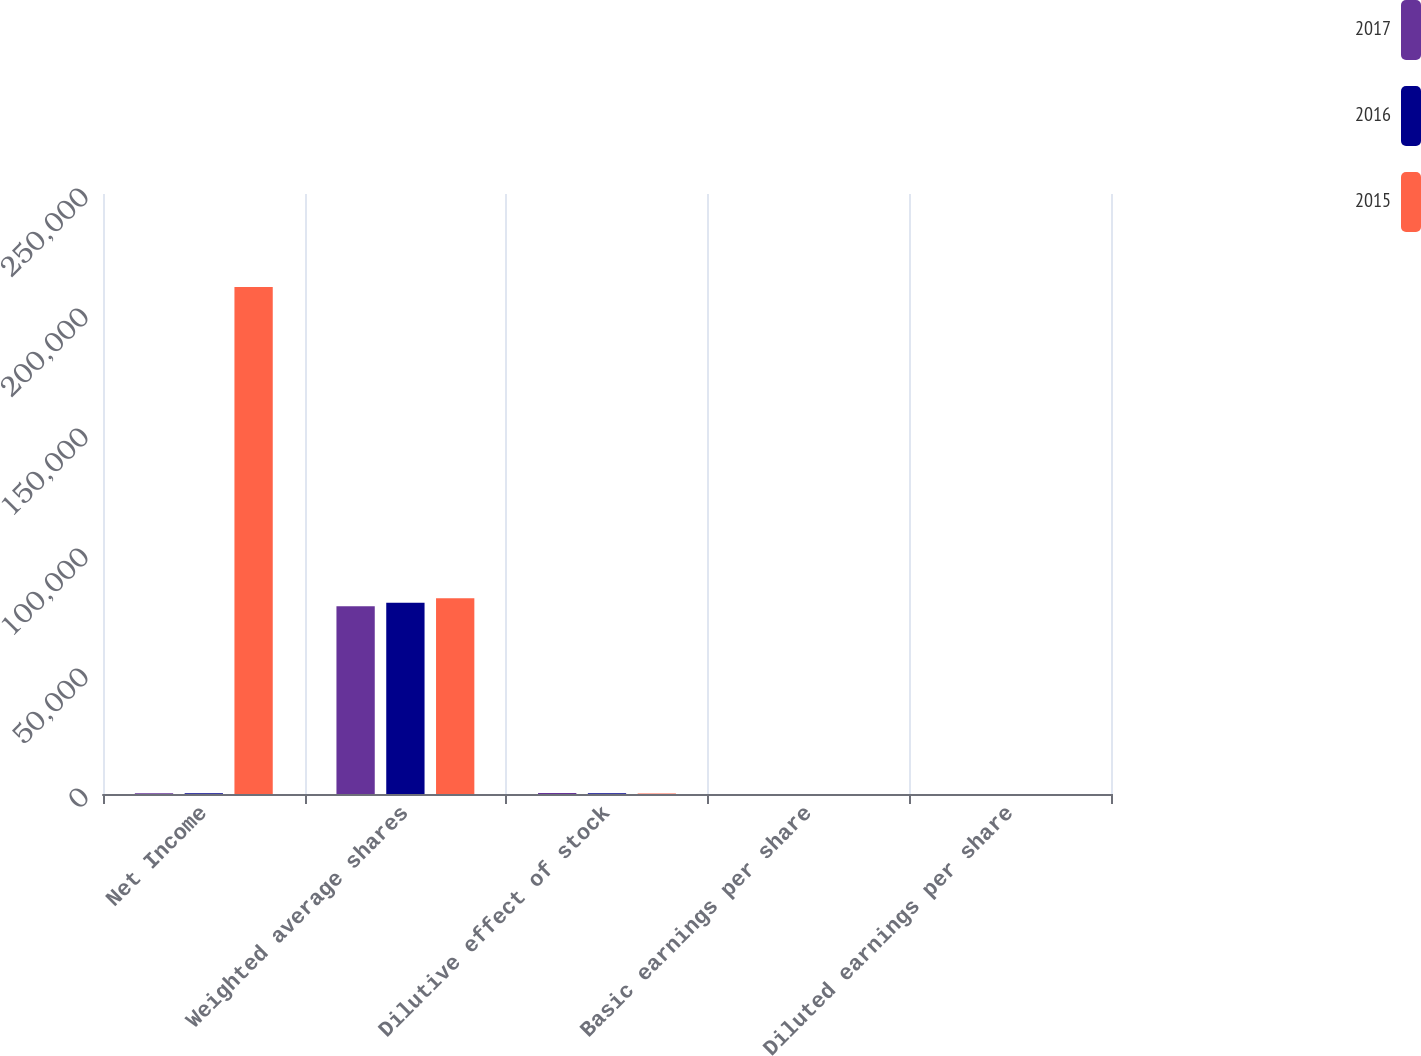Convert chart. <chart><loc_0><loc_0><loc_500><loc_500><stacked_bar_chart><ecel><fcel>Net Income<fcel>Weighted average shares<fcel>Dilutive effect of stock<fcel>Basic earnings per share<fcel>Diluted earnings per share<nl><fcel>2017<fcel>358.5<fcel>78255<fcel>399<fcel>3.16<fcel>3.14<nl><fcel>2016<fcel>358.5<fcel>79734<fcel>318<fcel>3.13<fcel>3.12<nl><fcel>2015<fcel>211221<fcel>81601<fcel>248<fcel>2.6<fcel>2.59<nl></chart> 